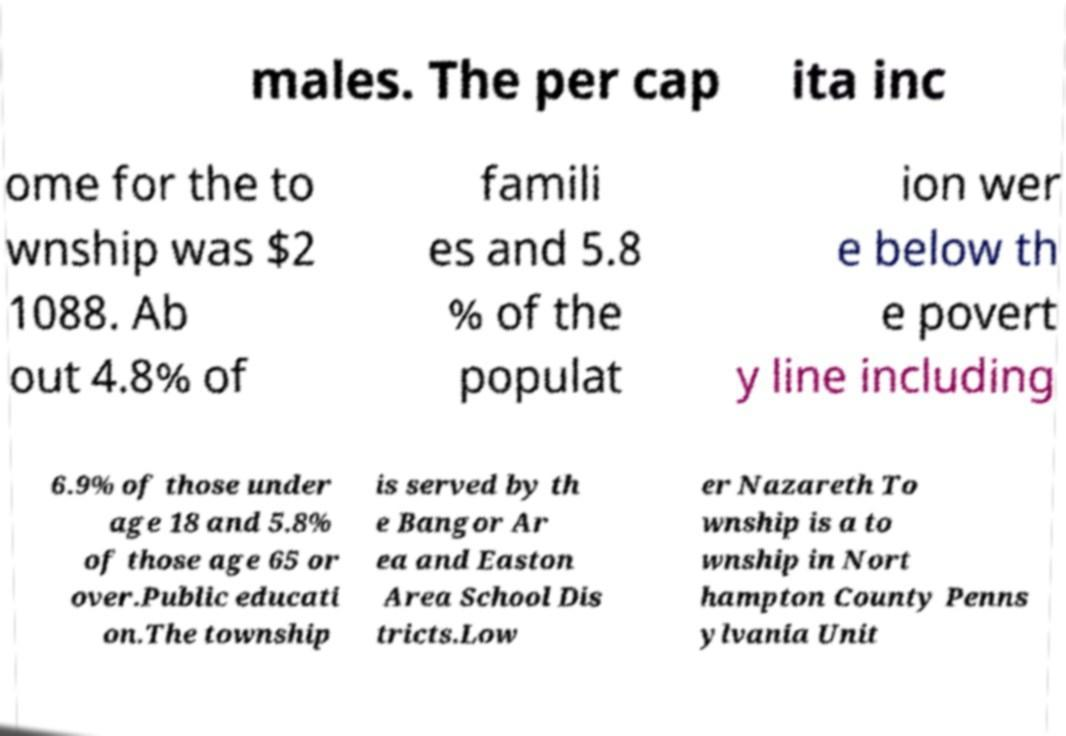Please read and relay the text visible in this image. What does it say? males. The per cap ita inc ome for the to wnship was $2 1088. Ab out 4.8% of famili es and 5.8 % of the populat ion wer e below th e povert y line including 6.9% of those under age 18 and 5.8% of those age 65 or over.Public educati on.The township is served by th e Bangor Ar ea and Easton Area School Dis tricts.Low er Nazareth To wnship is a to wnship in Nort hampton County Penns ylvania Unit 